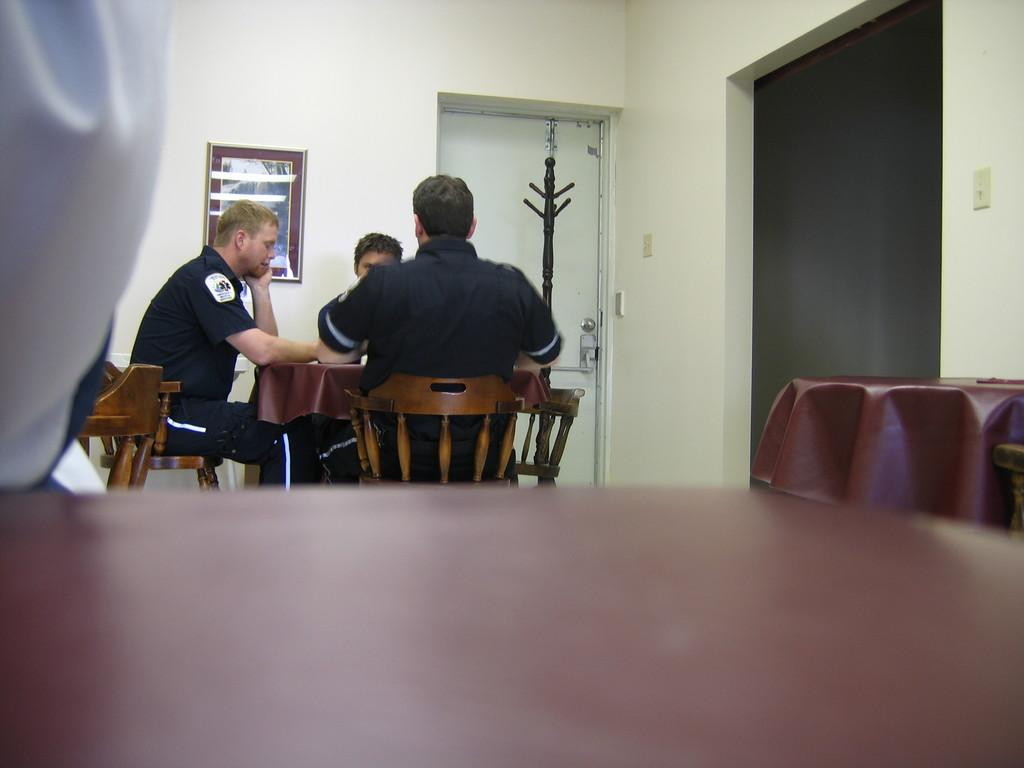How many people are in the image? There are three persons in the image. What are the persons doing in the image? The persons are sitting on chairs. What furniture can be seen in the image besides the chairs? There are tables in the image. What can be seen in the background of the image? There is a wall, a photo frame, and a door in the background of the image. What type of punishment is being carried out in the image? There is no indication of any punishment being carried out in the image; the persons are simply sitting on chairs. 